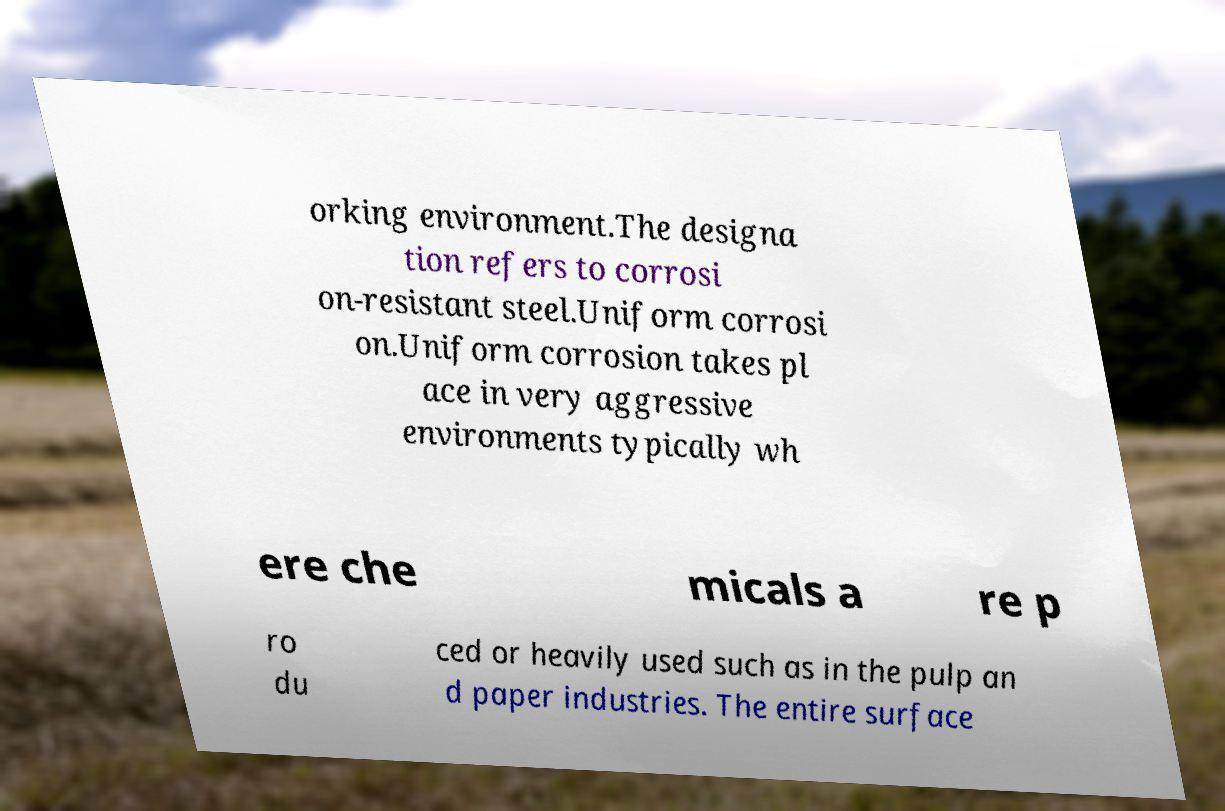There's text embedded in this image that I need extracted. Can you transcribe it verbatim? orking environment.The designa tion refers to corrosi on-resistant steel.Uniform corrosi on.Uniform corrosion takes pl ace in very aggressive environments typically wh ere che micals a re p ro du ced or heavily used such as in the pulp an d paper industries. The entire surface 